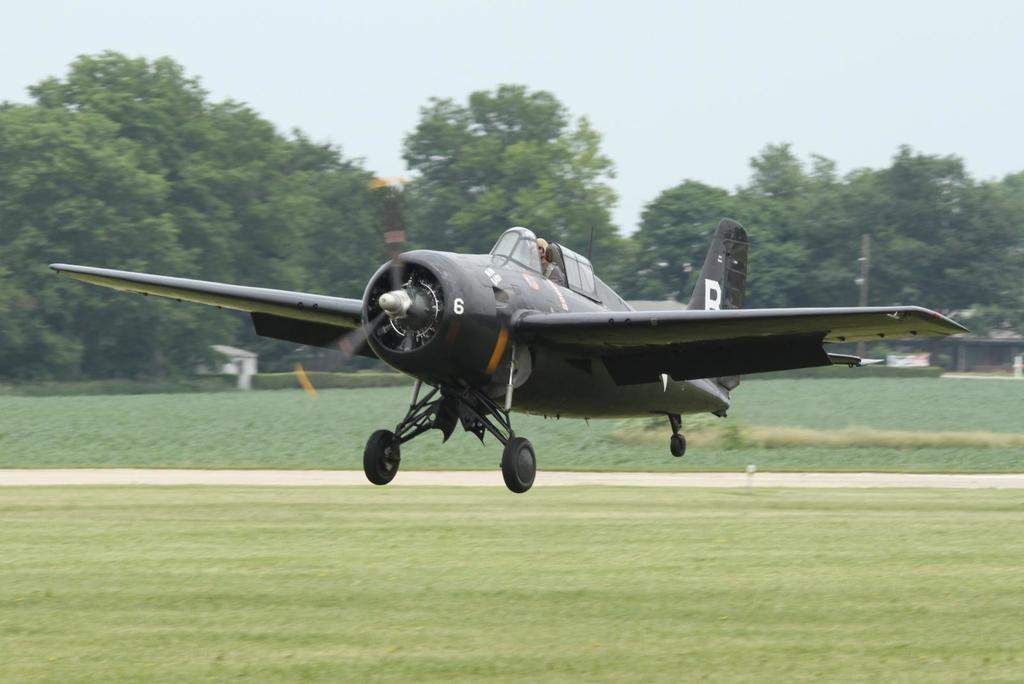What is the main subject of the image? The main subject of the image is an airplane. What type of natural environment is visible in the image? There are trees and grass visible in the image. What type of structure can be seen in the image? There is a building in the image. What is visible in the background of the image? The sky is visible in the background of the image. Can you tell me how many bananas are hanging from the trees in the image? There are no bananas visible in the image; only trees are present. What type of salt is being used to season the grass in the image? There is no salt or any indication of seasoning in the image; it only shows grass. 